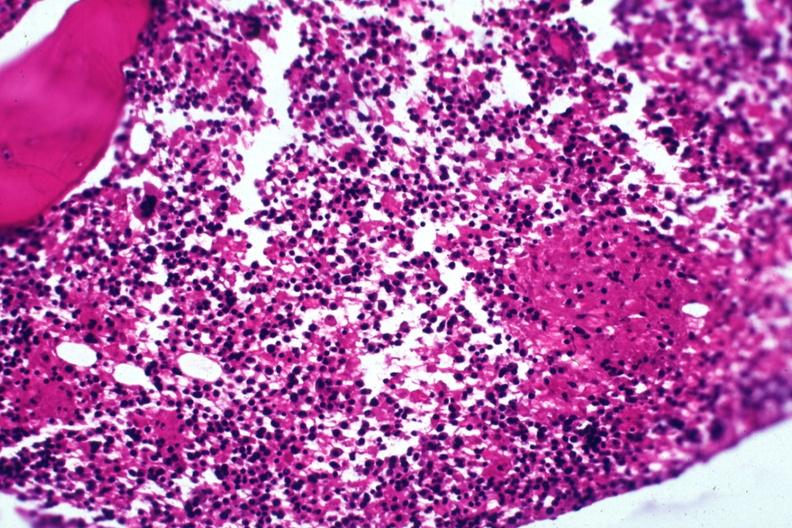s bone marrow present?
Answer the question using a single word or phrase. Yes 